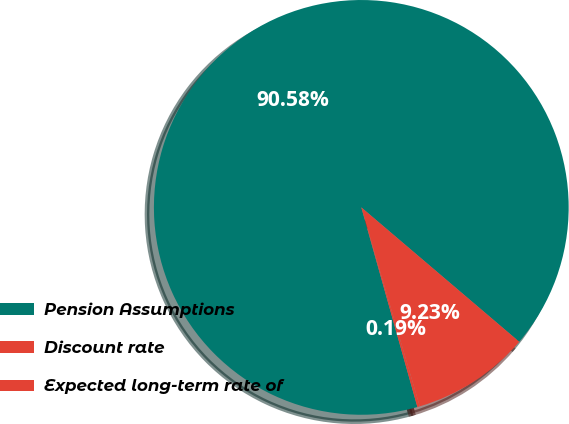Convert chart. <chart><loc_0><loc_0><loc_500><loc_500><pie_chart><fcel>Pension Assumptions<fcel>Discount rate<fcel>Expected long-term rate of<nl><fcel>90.59%<fcel>0.19%<fcel>9.23%<nl></chart> 